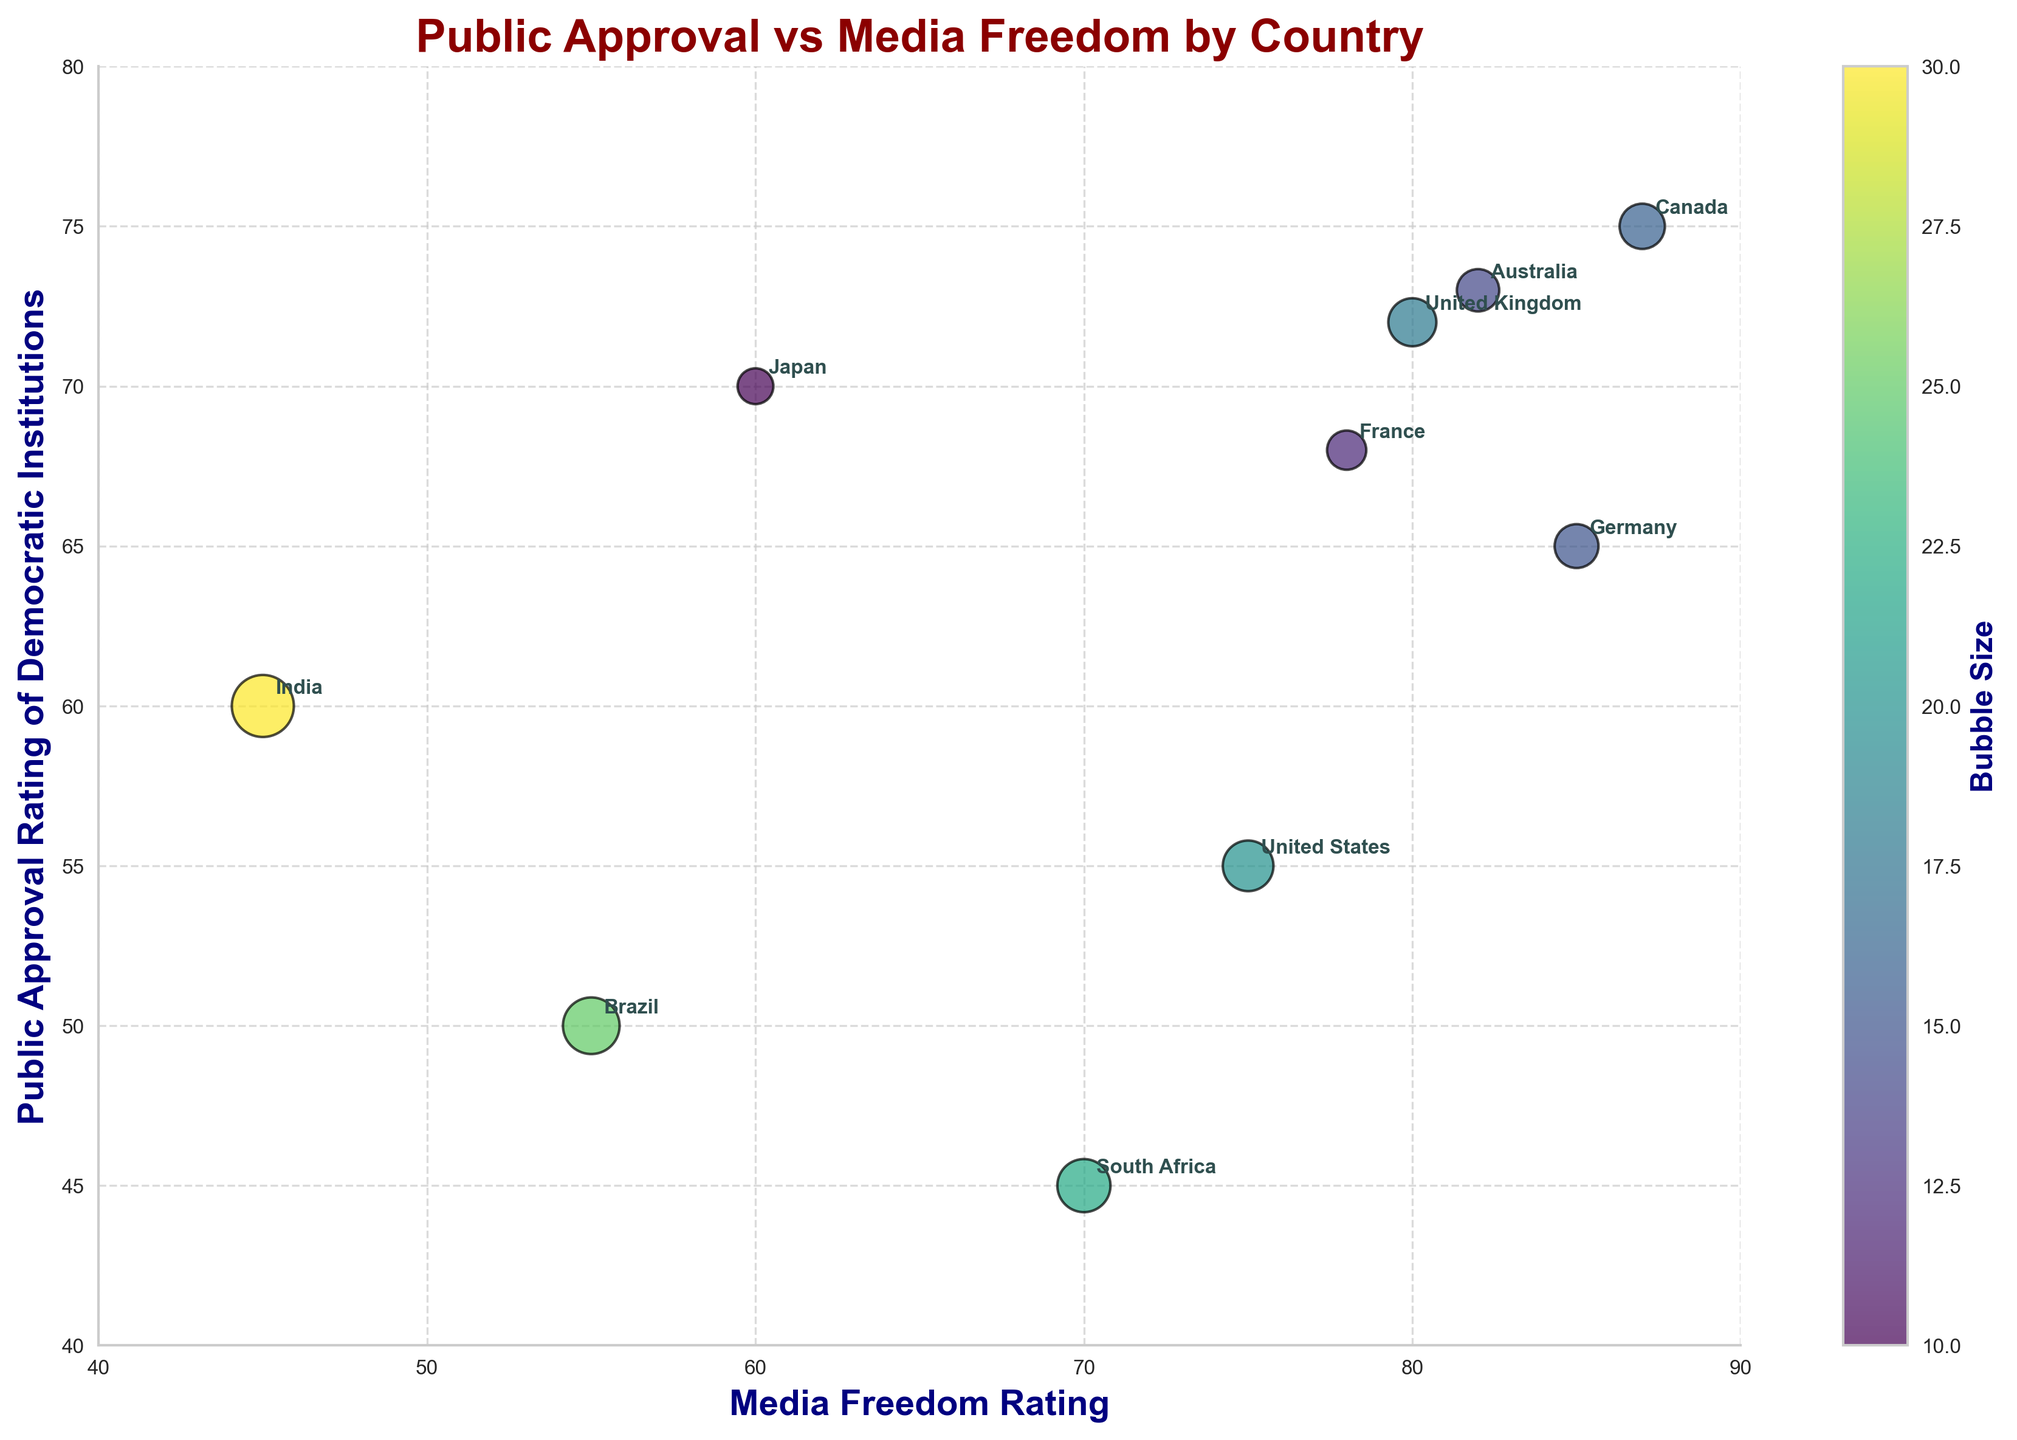what is the title of the bubble chart? The title of the bubble chart is prominently displayed at the top of the figure and is written as "Public Approval vs Media Freedom by Country".
Answer: Public Approval vs Media Freedom by Country Which country has the highest public approval rating for democratic institutions? To find which country has the highest public approval rating for democratic institutions, look for the bubble positioned highest on the y-axis. The label associated with this highest bubble is "Canada" at 75.
Answer: Canada What are the axis labels? The x-axis label is "Media Freedom Rating" and the y-axis label is "Public Approval Rating of Democratic Institutions," which are clearly stated along the respective axes.
Answer: Media Freedom Rating, Public Approval Rating of Democratic Institutions Which country has a media freedom rating of 60? Locate the bubble directly above the x-axis value of 60 and refer to the country label beside this bubble, which is "Japan."
Answer: Japan What is the public approval rating of democratic institutions in Germany? Find the bubble labeled "Germany," and then read the corresponding y-axis value, which indicates a public approval rating of 65.
Answer: 65 Compare the media freedom ratings of the United States and the United Kingdom. Which country has a higher rating? Identify the bubbles for the United States and the United Kingdom on the x-axis and note their respective positions. The United States has a rating of 75, while the United Kingdom has a rating of 80.
Answer: United Kingdom Which two countries have the smallest and largest bubble sizes? Compare the sizes of the bubbles visually. The smallest bubble belongs to "Japan," while the largest bubble is for "India" due to the visual area they occupy.
Answer: Japan, India What is the average media freedom rating of all countries shown in the chart? Compute the average by summing the media freedom ratings of all countries (75+85+60+55+45+80+70+78+87+82) and dividing by the number of countries (10).
Answer: (75+85+60+55+45+80+70+78+87+82)/10 = 71.7 Is there a country with both high public approval and high media freedom rating close to each other? Find bubbles that are high on both x and y axes. The country "Canada" stands out with a public approval rating of 75 and a media freedom rating of 87, both relatively high values.
Answer: Canada Which country shows relatively low values in both media freedom and public approval ratings? Identify the bubble low on both x and y axes. "Brazil" shows lower values in both dimensions with a public approval rating of 50 and a media freedom rating of 55.
Answer: Brazil 